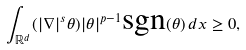<formula> <loc_0><loc_0><loc_500><loc_500>\int _ { \mathbb { R } ^ { d } } ( | \nabla | ^ { s } \theta ) | \theta | ^ { p - 1 } \text {sgn} ( \theta ) \, d x \geq 0 ,</formula> 